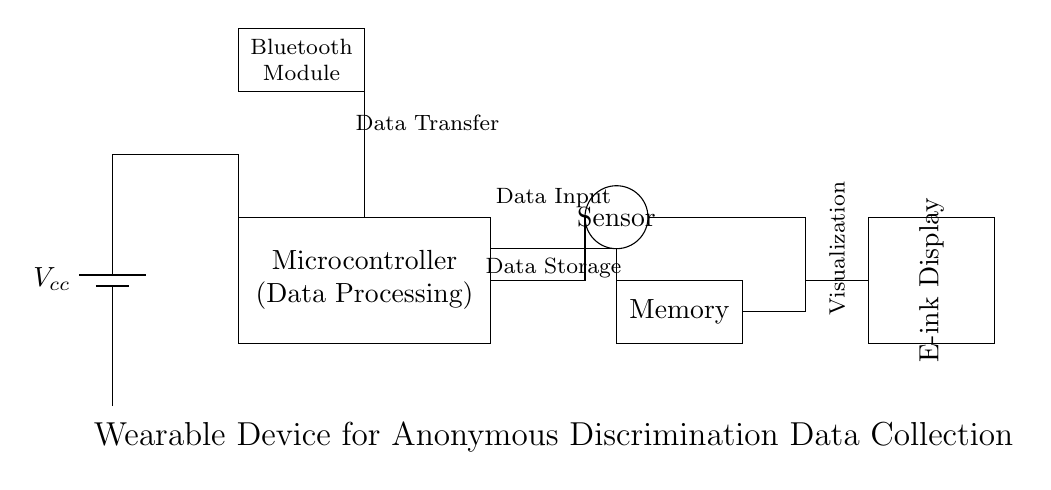What is the main power supply component in the circuit? The main power supply component is a battery, which provides the necessary voltage for the circuit.
Answer: Battery What type of display is used in the wearable device? The display used is an e-ink display, known for its low power consumption and visibility under sunlight.
Answer: E-ink Display How many main components are used in this circuit? There are five main components: battery, microcontroller, sensor, memory, and e-ink display, forming the core of the device’s functionality.
Answer: Five What is the purpose of the Bluetooth module in the circuit? The Bluetooth module is used for data transfer, allowing the device to communicate with other devices wirelessly.
Answer: Data Transfer What does the microcontroller do in this circuit? The microcontroller is responsible for data processing, managing input from the sensor, processing that data, and sending it to memory or to be visualized.
Answer: Data Processing Which components are directly involved in data storage? The memory component is directly responsible for storing the data collected by the device for later retrieval and analysis.
Answer: Memory Which component provides input data to the system? The input data to the system is collected by the sensor, which detects and gathers information about discrimination incidents.
Answer: Sensor 